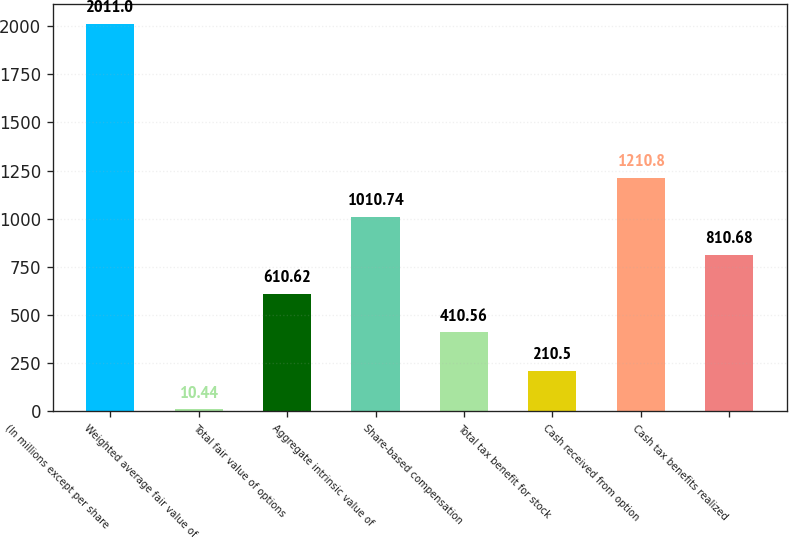<chart> <loc_0><loc_0><loc_500><loc_500><bar_chart><fcel>(In millions except per share<fcel>Weighted average fair value of<fcel>Total fair value of options<fcel>Aggregate intrinsic value of<fcel>Share-based compensation<fcel>Total tax benefit for stock<fcel>Cash received from option<fcel>Cash tax benefits realized<nl><fcel>2011<fcel>10.44<fcel>610.62<fcel>1010.74<fcel>410.56<fcel>210.5<fcel>1210.8<fcel>810.68<nl></chart> 